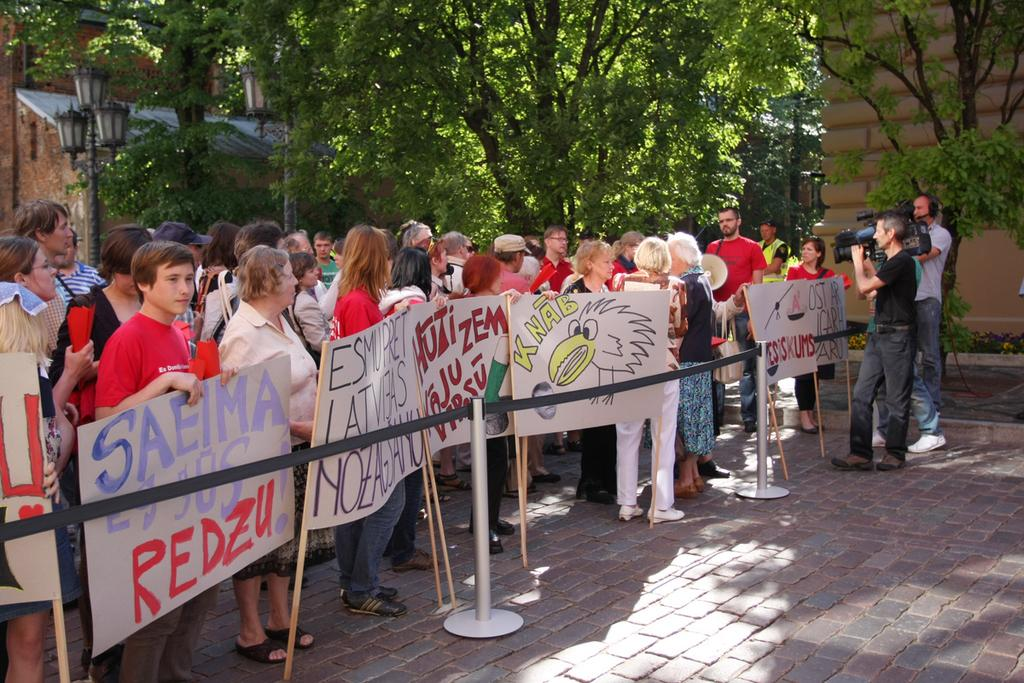What is in the foreground of the image? In the foreground of the image, there is a pavement, a safety pole, persons holding placards, and men holding cameras. What can be seen near the safety pole? Near the safety pole, there are persons holding placards and men holding cameras. What type of objects are present in the foreground of the image? In the foreground of the image, there is a safety pole, a light pole, and a pavement. What else is visible in the image besides the foreground? In the image, there are trees and buildings. What type of glass object is being used to act as a barrier between the trees and the buildings in the image? There is no glass object present in the image, nor is there any indication of an object being used as a barrier between the trees and the buildings. 